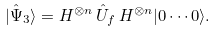<formula> <loc_0><loc_0><loc_500><loc_500>| \hat { \Psi } _ { 3 } \rangle = H ^ { \otimes n } \, \hat { U } _ { f } \, H ^ { \otimes n } | 0 \cdots 0 \rangle .</formula> 